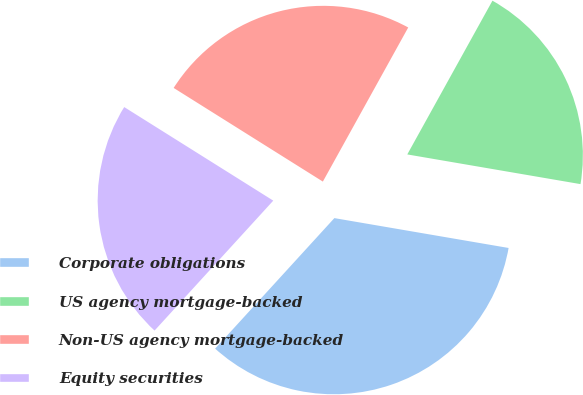<chart> <loc_0><loc_0><loc_500><loc_500><pie_chart><fcel>Corporate obligations<fcel>US agency mortgage-backed<fcel>Non-US agency mortgage-backed<fcel>Equity securities<nl><fcel>34.08%<fcel>19.65%<fcel>24.13%<fcel>22.14%<nl></chart> 